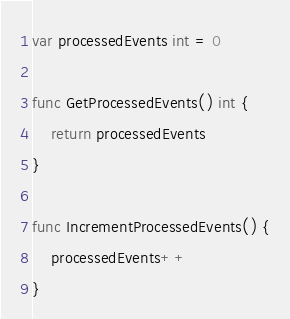<code> <loc_0><loc_0><loc_500><loc_500><_Go_>
var processedEvents int = 0

func GetProcessedEvents() int {
    return processedEvents
}

func IncrementProcessedEvents() {
    processedEvents++
}
</code> 